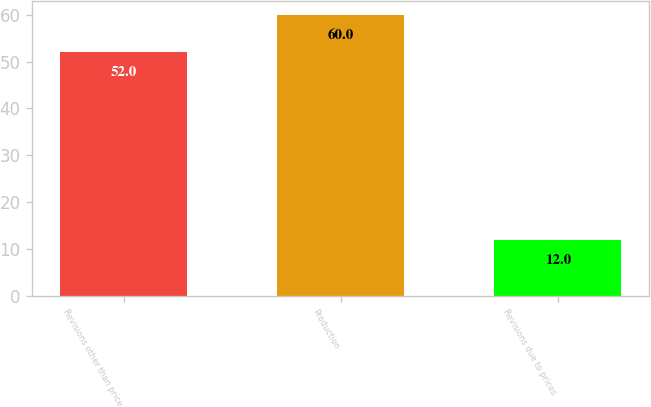Convert chart to OTSL. <chart><loc_0><loc_0><loc_500><loc_500><bar_chart><fcel>Revisions other than price<fcel>Production<fcel>Revisions due to prices<nl><fcel>52<fcel>60<fcel>12<nl></chart> 